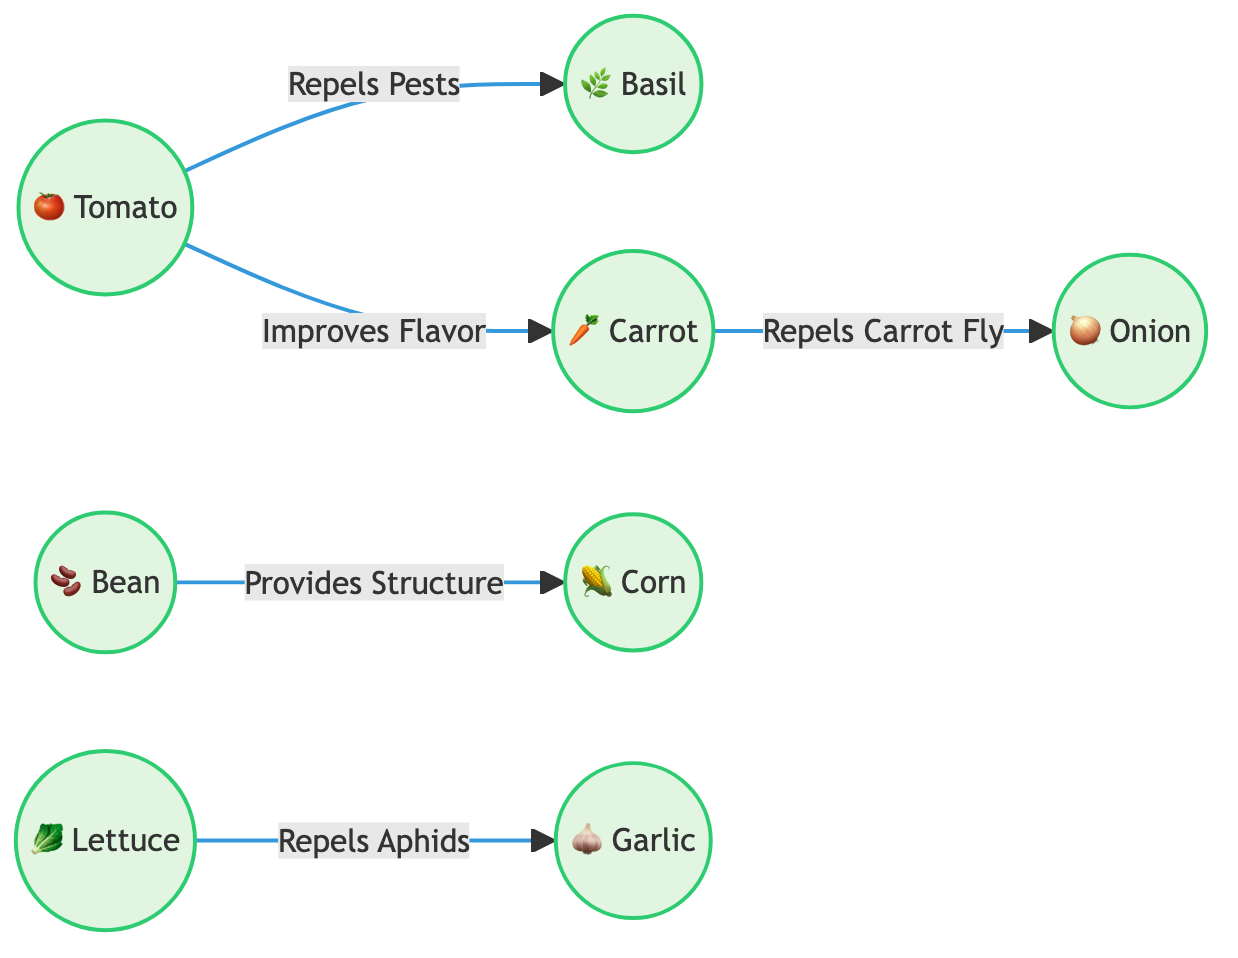What plants repel pests from tomatoes? The diagram shows that basil is connected to tomatoes with the edge labeled "Repels Pests." Therefore, basil is indicated as a plant that repels pests from tomatoes.
Answer: basil How many plants are shown in the diagram? The diagram contains 8 distinct plant nodes: tomato, basil, carrot, onion, bean, corn, lettuce, and garlic. Counting these gives a total of 8 plants.
Answer: 8 What does carrot repel? The edge between the carrot and onion in the diagram indicates that carrot repels "Carrot Fly." Thus, the answer is that carrot repels carrot fly.
Answer: Carrot Fly Which plant improves the flavor of carrots? The arrow between the tomato and carrot, labeled "Improves Flavor," indicates that tomatoes improve the flavor of carrots.
Answer: tomato What is the relationship between beans and corn? The diagram highlights that beans provide structure for corn, indicated by the edge labeled "Provides Structure" connecting the two plants.
Answer: Provides Structure Which plant is connected to garlic in the diagram? The diagram shows lettuce connected to garlic with the label "Repels Aphids," which indicates that lettuce is related to garlic.
Answer: lettuce How many edges are present in the diagram? Counting the connections (edges) between the plants in the diagram shows 6 edges: tomato-basil, carrot-onion, bean-corn, lettuce-garlic, tomato-carrot refers to different relationships.
Answer: 6 What are the two plants that have a direct connection without pest control or flavor enhancement? The beans and corn connection is labeled "Provides Structure," which does not involve pest control or flavor enhancement. This signifies that beans and corn have a direct relationship centered on supportive growth rather than any other strategic benefits.
Answer: beans, corn What benefits do tomatoes provide to carrots? The diagram indicates that tomatoes improve the flavor of carrots, and this edge is directly labeled.
Answer: Improves Flavor 